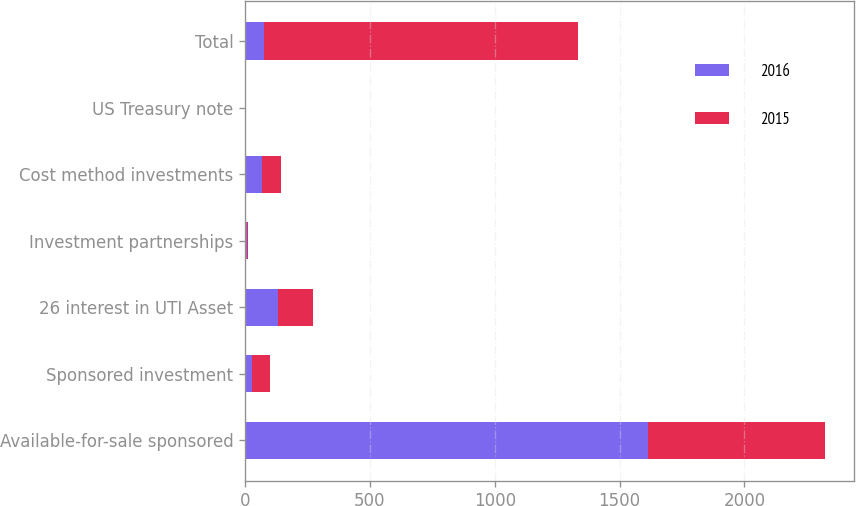Convert chart to OTSL. <chart><loc_0><loc_0><loc_500><loc_500><stacked_bar_chart><ecel><fcel>Available-for-sale sponsored<fcel>Sponsored investment<fcel>26 interest in UTI Asset<fcel>Investment partnerships<fcel>Cost method investments<fcel>US Treasury note<fcel>Total<nl><fcel>2016<fcel>1612.3<fcel>25.8<fcel>132.8<fcel>6.2<fcel>69.4<fcel>1<fcel>75.4<nl><fcel>2015<fcel>709<fcel>75.4<fcel>140.9<fcel>5.3<fcel>73.6<fcel>1<fcel>1257.5<nl></chart> 